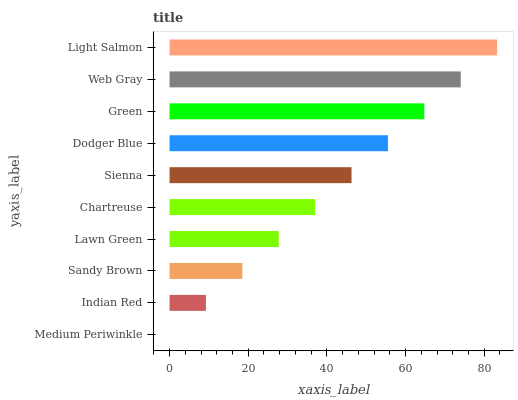Is Medium Periwinkle the minimum?
Answer yes or no. Yes. Is Light Salmon the maximum?
Answer yes or no. Yes. Is Indian Red the minimum?
Answer yes or no. No. Is Indian Red the maximum?
Answer yes or no. No. Is Indian Red greater than Medium Periwinkle?
Answer yes or no. Yes. Is Medium Periwinkle less than Indian Red?
Answer yes or no. Yes. Is Medium Periwinkle greater than Indian Red?
Answer yes or no. No. Is Indian Red less than Medium Periwinkle?
Answer yes or no. No. Is Sienna the high median?
Answer yes or no. Yes. Is Chartreuse the low median?
Answer yes or no. Yes. Is Light Salmon the high median?
Answer yes or no. No. Is Sandy Brown the low median?
Answer yes or no. No. 